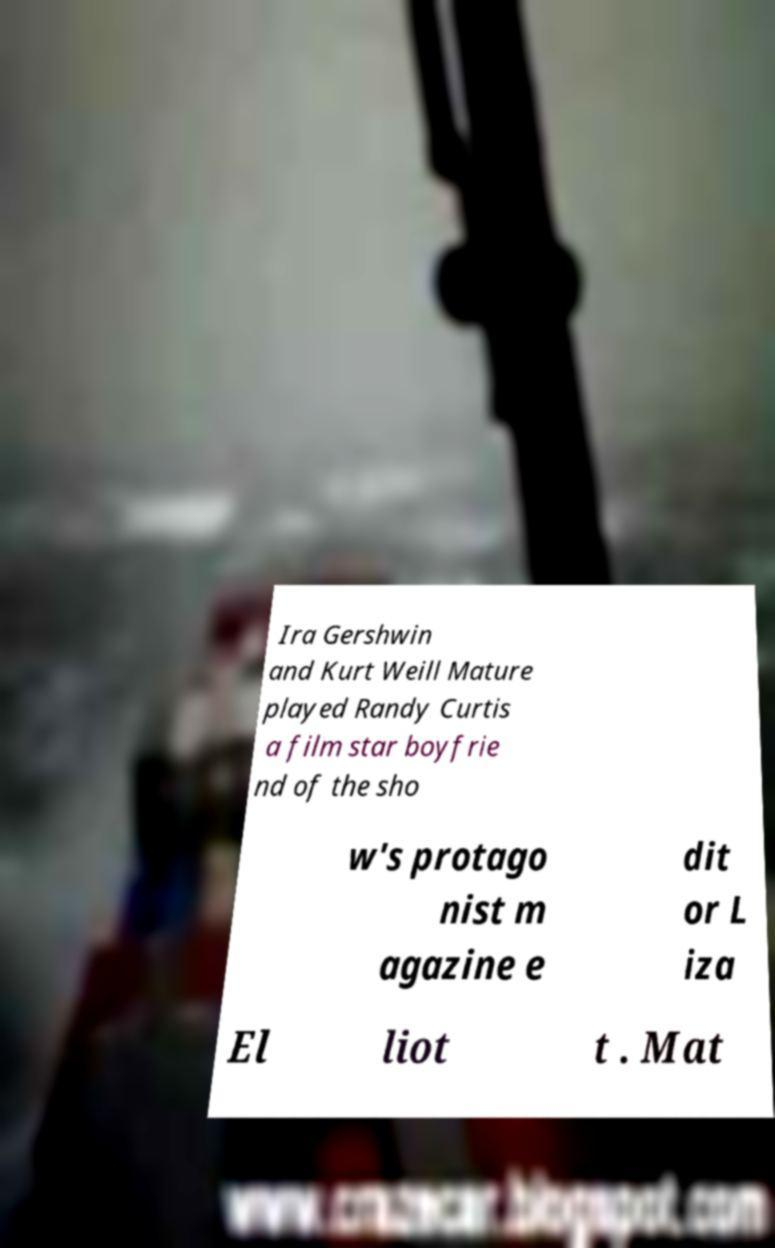Can you accurately transcribe the text from the provided image for me? Ira Gershwin and Kurt Weill Mature played Randy Curtis a film star boyfrie nd of the sho w's protago nist m agazine e dit or L iza El liot t . Mat 